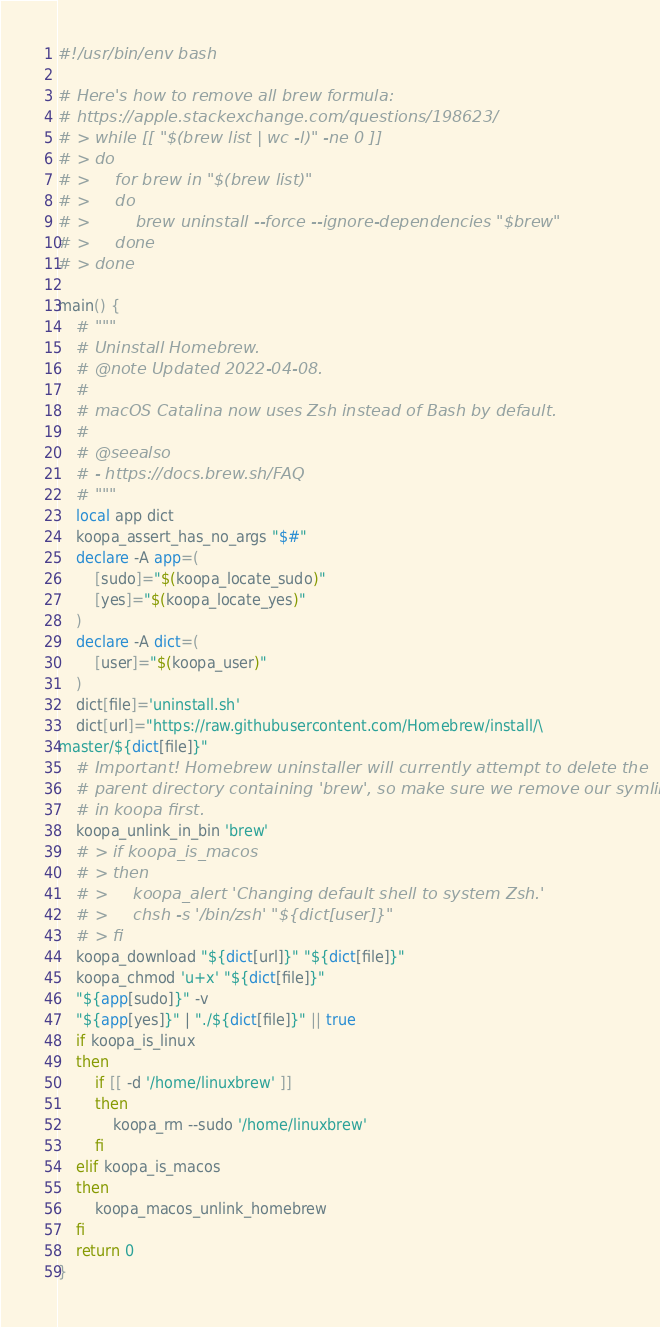<code> <loc_0><loc_0><loc_500><loc_500><_Bash_>#!/usr/bin/env bash

# Here's how to remove all brew formula:
# https://apple.stackexchange.com/questions/198623/
# > while [[ "$(brew list | wc -l)" -ne 0 ]]
# > do
# >     for brew in "$(brew list)"
# >     do
# >         brew uninstall --force --ignore-dependencies "$brew"
# >     done
# > done

main() {
    # """
    # Uninstall Homebrew.
    # @note Updated 2022-04-08.
    #
    # macOS Catalina now uses Zsh instead of Bash by default.
    #
    # @seealso
    # - https://docs.brew.sh/FAQ
    # """
    local app dict
    koopa_assert_has_no_args "$#"
    declare -A app=(
        [sudo]="$(koopa_locate_sudo)"
        [yes]="$(koopa_locate_yes)"
    )
    declare -A dict=(
        [user]="$(koopa_user)"
    )
    dict[file]='uninstall.sh'
    dict[url]="https://raw.githubusercontent.com/Homebrew/install/\
master/${dict[file]}"
    # Important! Homebrew uninstaller will currently attempt to delete the
    # parent directory containing 'brew', so make sure we remove our symlink
    # in koopa first.
    koopa_unlink_in_bin 'brew'
    # > if koopa_is_macos
    # > then
    # >     koopa_alert 'Changing default shell to system Zsh.'
    # >     chsh -s '/bin/zsh' "${dict[user]}"
    # > fi
    koopa_download "${dict[url]}" "${dict[file]}"
    koopa_chmod 'u+x' "${dict[file]}"
    "${app[sudo]}" -v
    "${app[yes]}" | "./${dict[file]}" || true
    if koopa_is_linux
    then
        if [[ -d '/home/linuxbrew' ]]
        then
            koopa_rm --sudo '/home/linuxbrew'
        fi
    elif koopa_is_macos
    then
        koopa_macos_unlink_homebrew
    fi
    return 0
}
</code> 